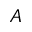Convert formula to latex. <formula><loc_0><loc_0><loc_500><loc_500>A</formula> 